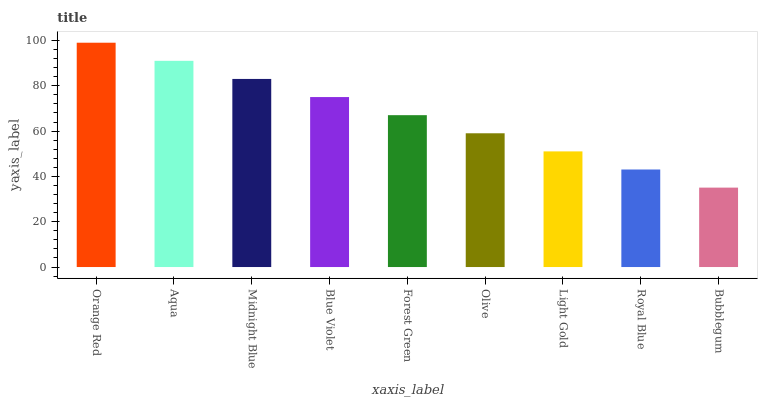Is Bubblegum the minimum?
Answer yes or no. Yes. Is Orange Red the maximum?
Answer yes or no. Yes. Is Aqua the minimum?
Answer yes or no. No. Is Aqua the maximum?
Answer yes or no. No. Is Orange Red greater than Aqua?
Answer yes or no. Yes. Is Aqua less than Orange Red?
Answer yes or no. Yes. Is Aqua greater than Orange Red?
Answer yes or no. No. Is Orange Red less than Aqua?
Answer yes or no. No. Is Forest Green the high median?
Answer yes or no. Yes. Is Forest Green the low median?
Answer yes or no. Yes. Is Bubblegum the high median?
Answer yes or no. No. Is Aqua the low median?
Answer yes or no. No. 